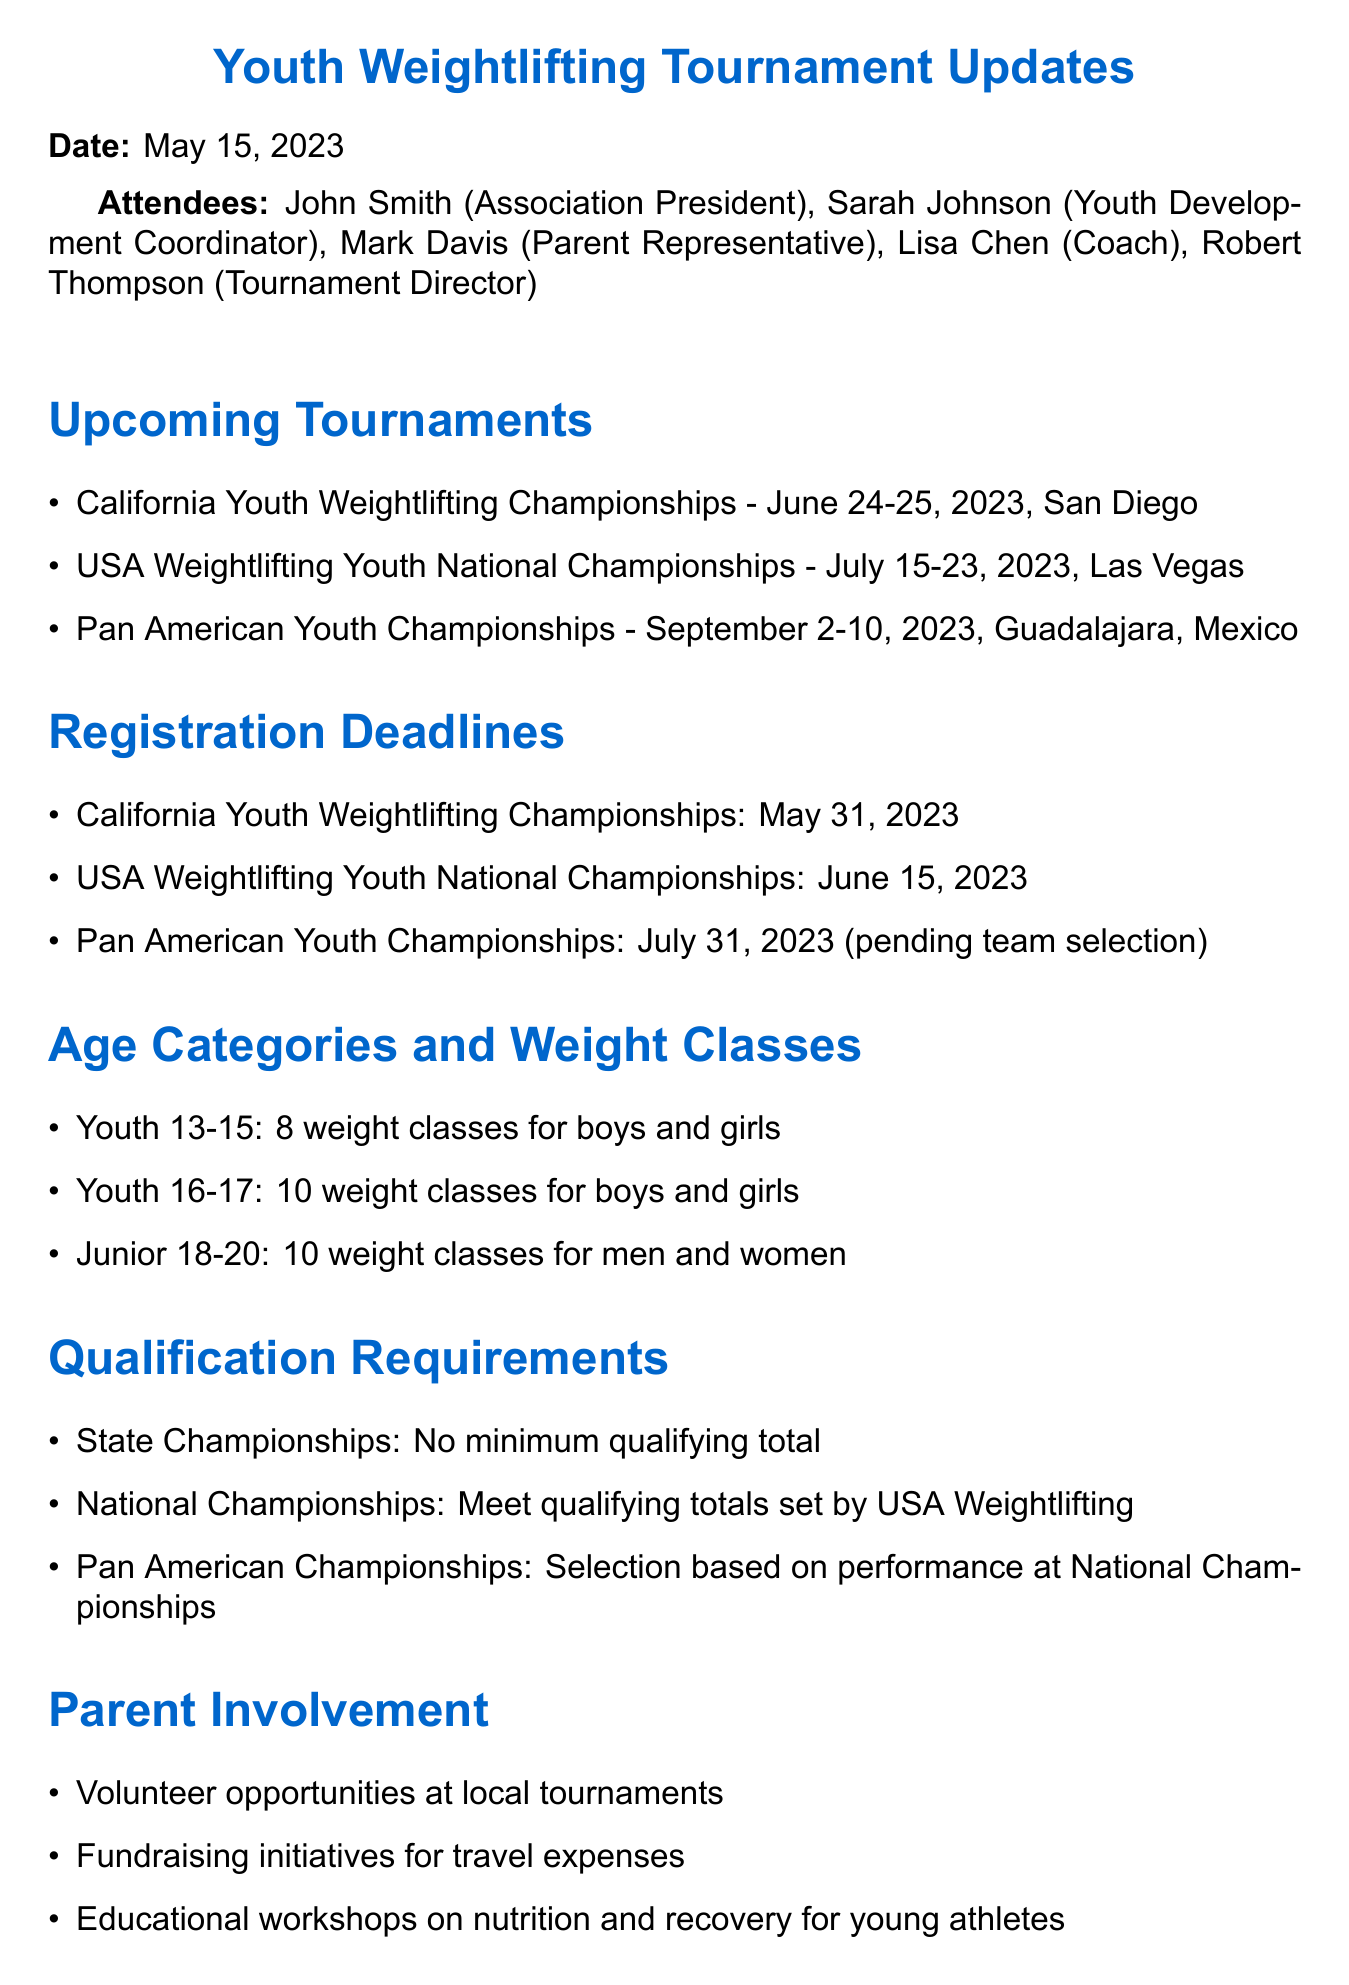What is the date of the California Youth Weightlifting Championships? The date for the California Youth Weightlifting Championships is specifically mentioned in the document as June 24-25, 2023.
Answer: June 24-25, 2023 What is the registration deadline for the USA Weightlifting Youth National Championships? The registration deadline for the USA Weightlifting Youth National Championships is clearly outlined as June 15, 2023.
Answer: June 15, 2023 How many weight classes are available for Youth aged 16-17? The document provides specific information about the number of weight classes for Youth 16-17, which is 10.
Answer: 10 What is the eligibility requirement for the State Championships? It is mentioned that there is no minimum qualifying total required for the State Championships, providing clarity on participation requirements.
Answer: No minimum qualifying total Who is the Tournament Director? The document lists the attendees, indicating that Robert Thompson holds the position of Tournament Director.
Answer: Robert Thompson What is the purpose of the parent meeting mentioned in the action items? The action item specifies that the parent meeting is scheduled to discuss fundraising options for the National Championships, providing clarity on its objective.
Answer: Discuss fundraising options for the National Championships What city will host the Pan American Youth Championships? The document mentions that the Pan American Youth Championships will take place in Guadalajara, Mexico, providing location details for this tournament.
Answer: Guadalajara, Mexico How many total tournaments are listed in the document? The document enumerates a total of three upcoming tournaments, providing a straightforward count.
Answer: 3 What type of involvement is encouraged for parents in local tournaments? The document suggests that parents can volunteer at local tournaments, indicating a supportive role for them.
Answer: Volunteer opportunities at local tournaments 